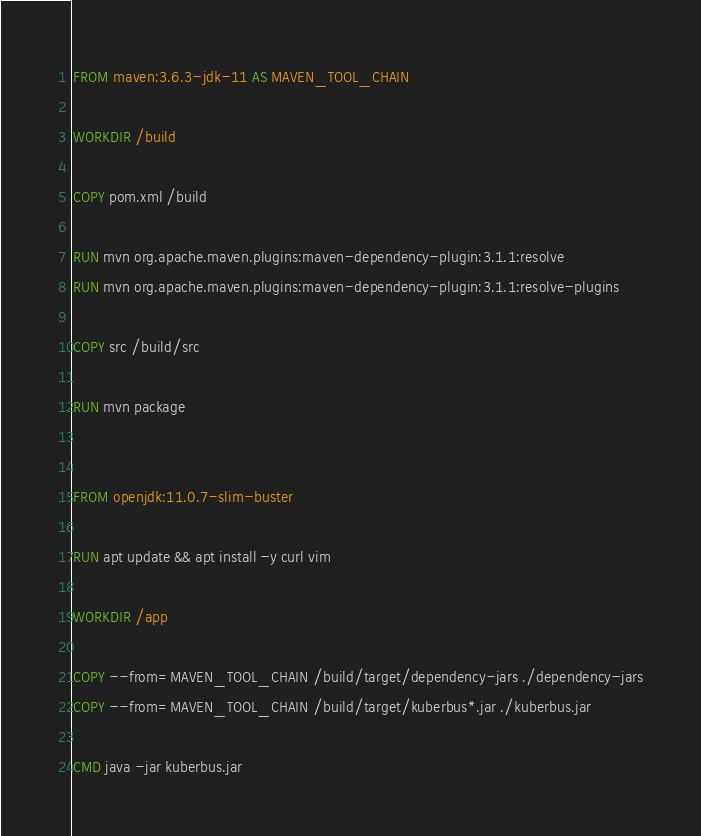Convert code to text. <code><loc_0><loc_0><loc_500><loc_500><_Dockerfile_>FROM maven:3.6.3-jdk-11 AS MAVEN_TOOL_CHAIN

WORKDIR /build

COPY pom.xml /build

RUN mvn org.apache.maven.plugins:maven-dependency-plugin:3.1.1:resolve
RUN mvn org.apache.maven.plugins:maven-dependency-plugin:3.1.1:resolve-plugins

COPY src /build/src

RUN mvn package


FROM openjdk:11.0.7-slim-buster

RUN apt update && apt install -y curl vim

WORKDIR /app

COPY --from=MAVEN_TOOL_CHAIN /build/target/dependency-jars ./dependency-jars
COPY --from=MAVEN_TOOL_CHAIN /build/target/kuberbus*.jar ./kuberbus.jar

CMD java -jar kuberbus.jar
</code> 